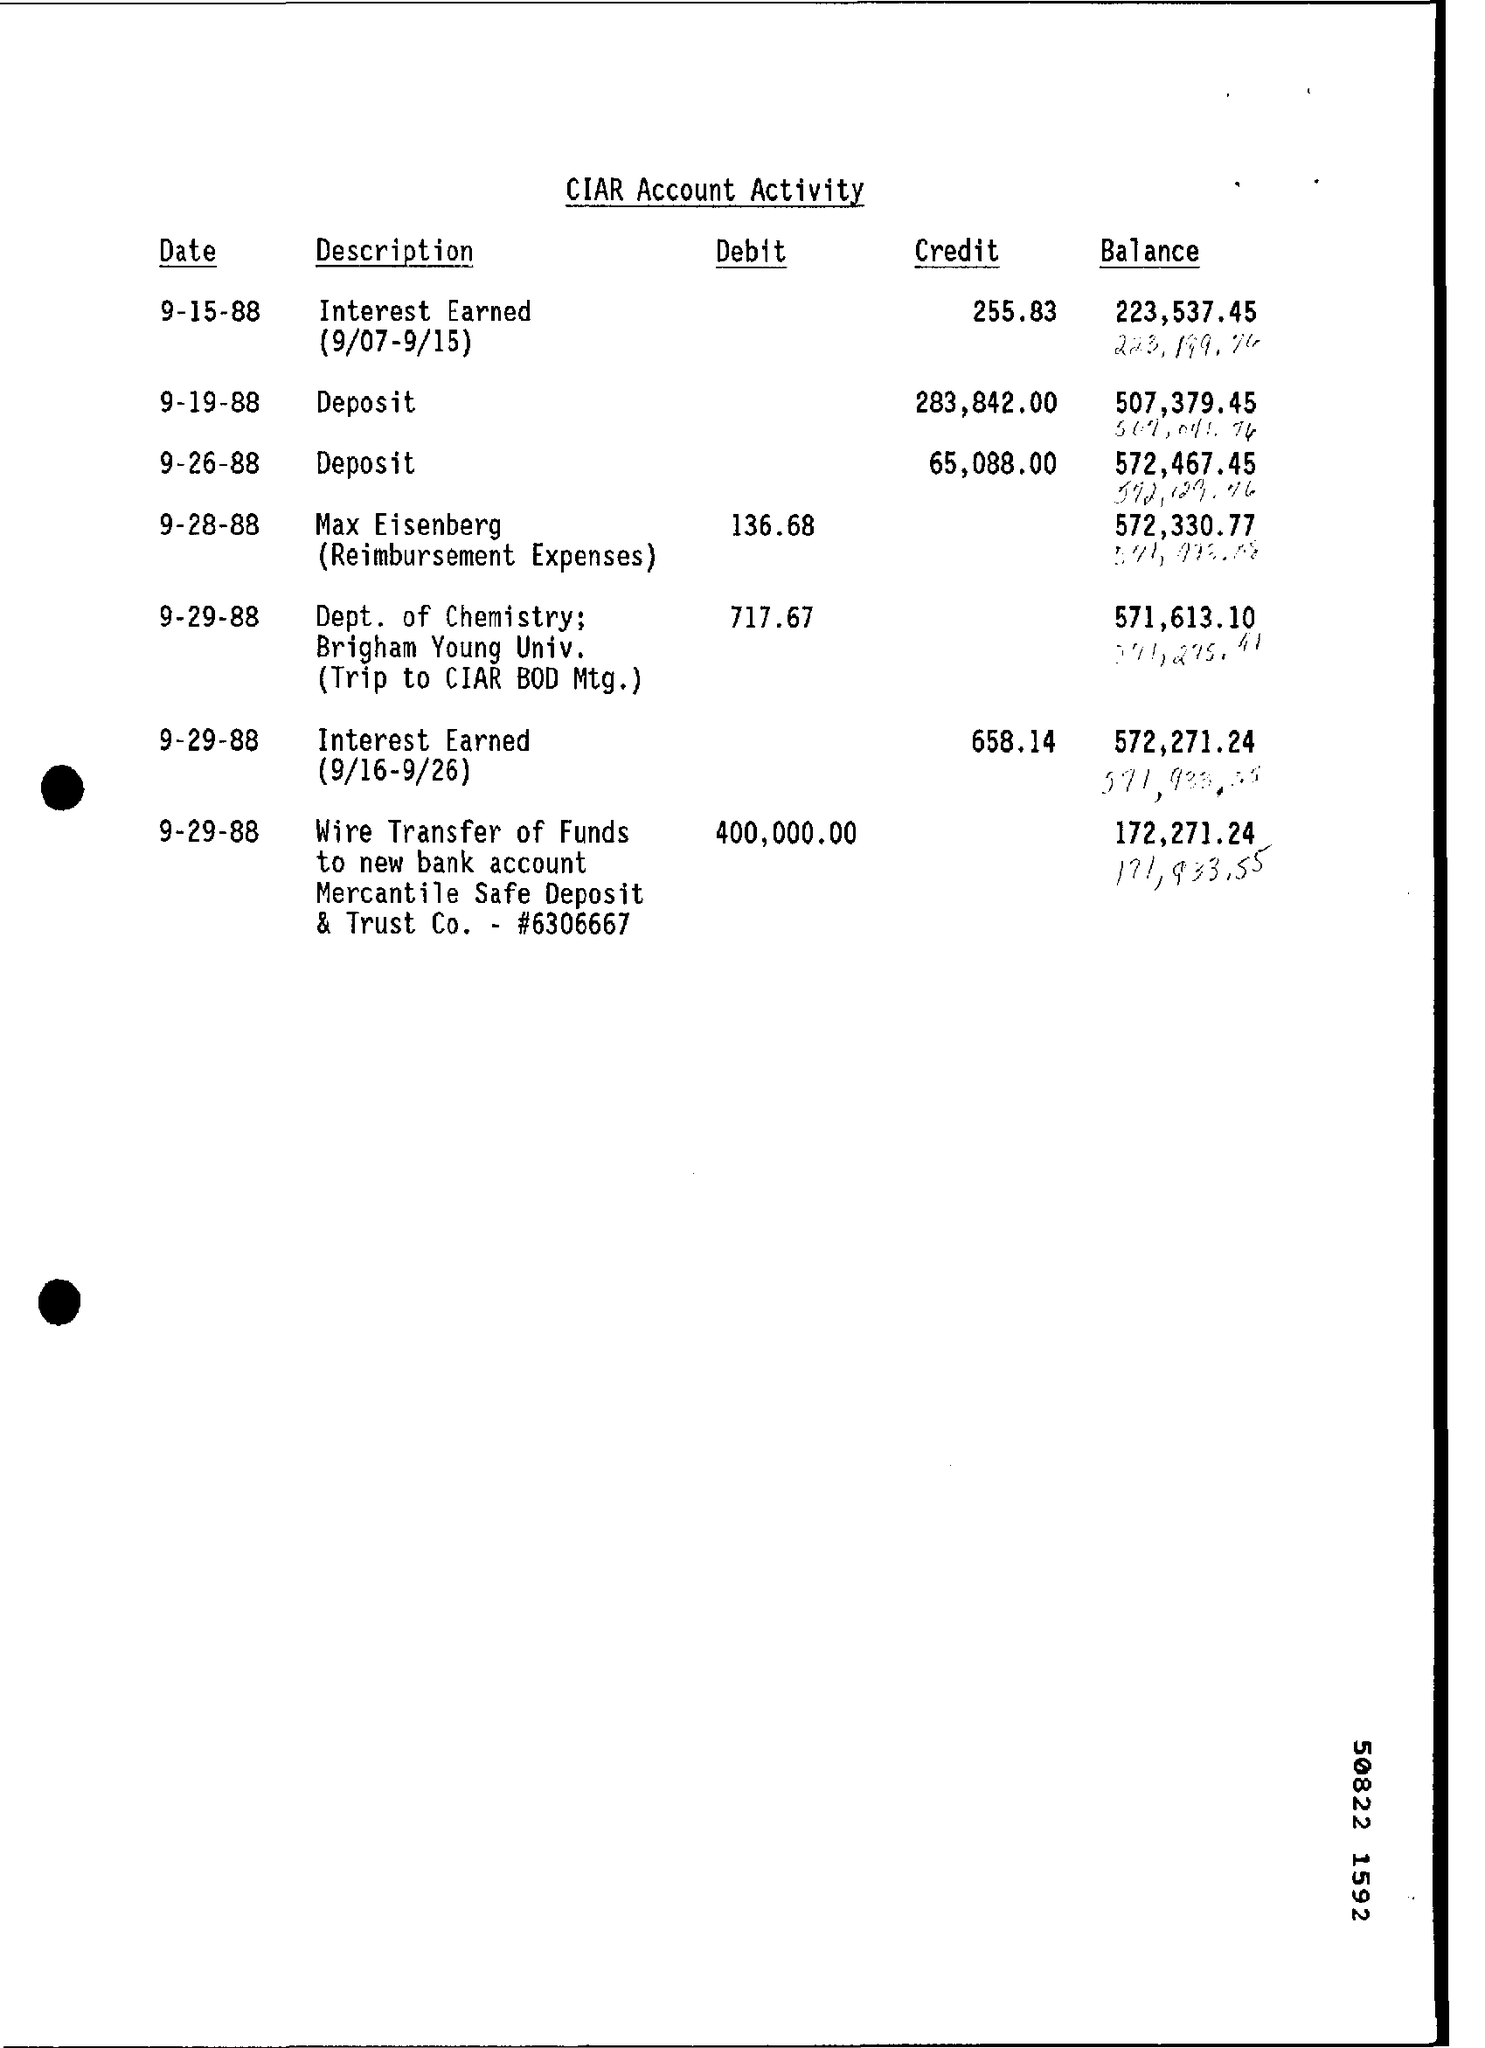How much amount is debited by merchant safe deposit & trust co on 9-29-88 ?
Offer a very short reply. 400,000.00. What is the description of credited amount 255.83 on 9-15-88 ?
Your answer should be very brief. Interest Earned (9/07-9/15). What is the description of credited amount of 65,088.00 on 9-26-88 ?
Ensure brevity in your answer.  Deposit. 